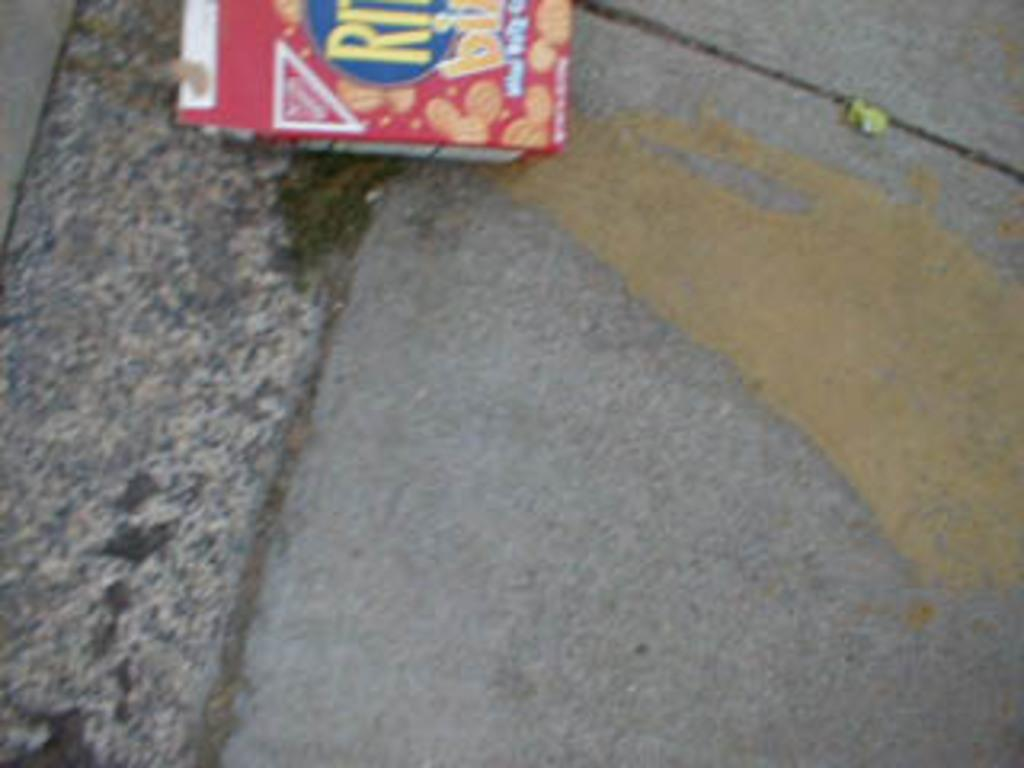What is the main subject on the ground in the image? There is an object on the ground in the image. What type of effect does the object have on the dinner in the image? There is no dinner present in the image, and therefore no such effect can be observed. 